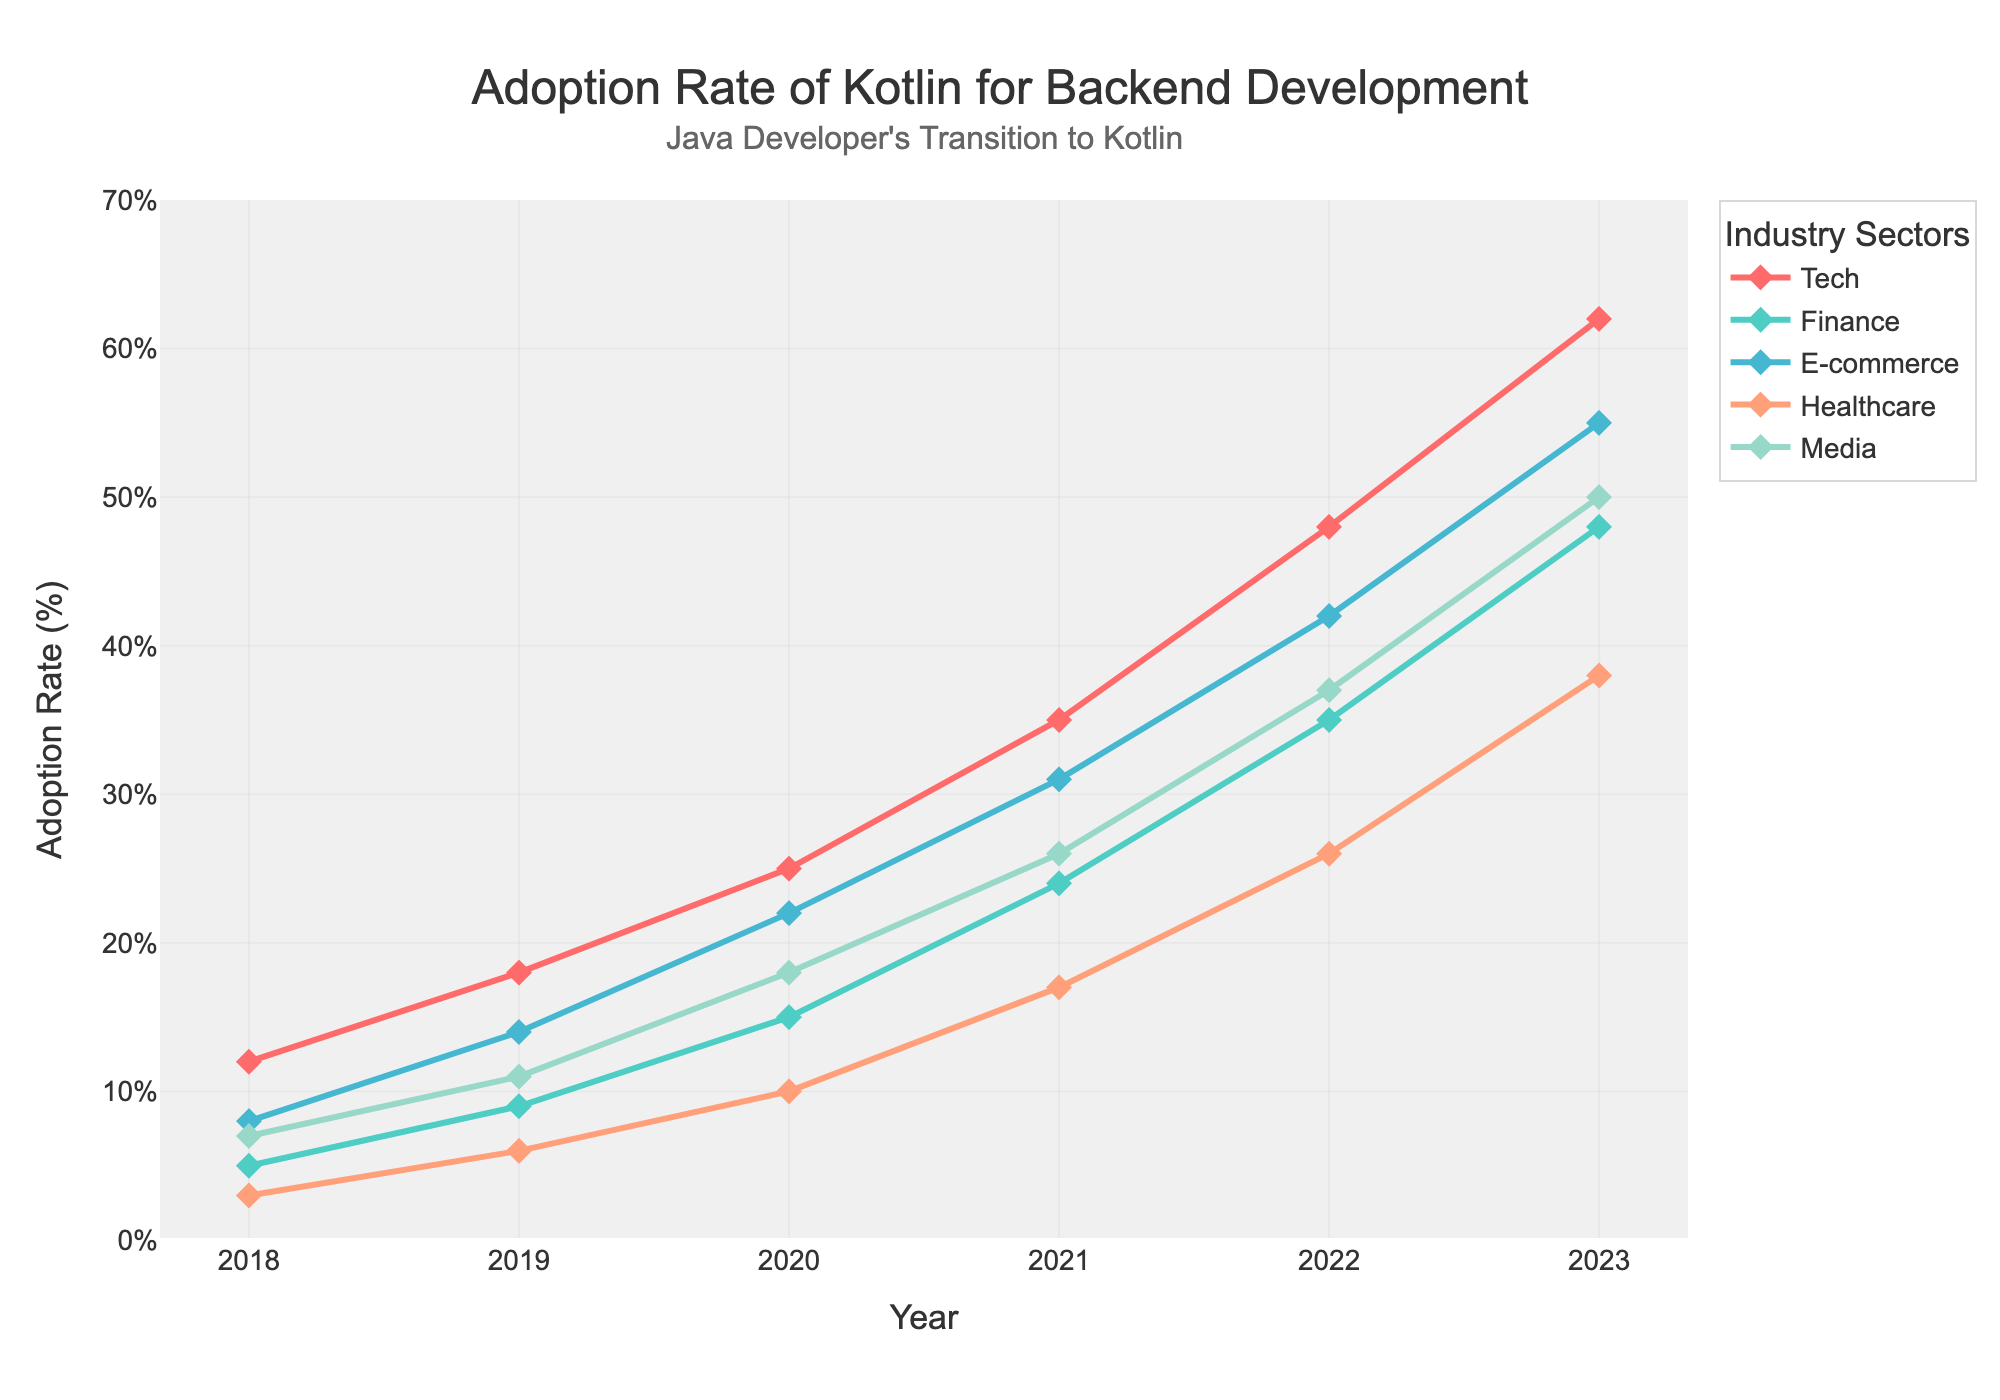What is the adoption rate of Kotlin in the Tech sector in 2020? Look at the line corresponding to the "Tech" sector and find the value for the year 2020.
Answer: 25% Between which years did the Finance sector see the highest increase in Kotlin adoption? Calculate the year-over-year differences in adoption rates for the Finance sector and compare them. The largest increase is between 2022 and 2023 (48 - 35 = 13).
Answer: 2022-2023 Which industry had the highest adoption rate of Kotlin in 2019? Look at the values for 2019 and compare the adoption rates across all industries. Identify the highest value.
Answer: E-commerce By how much did the Healthcare sector's Kotlin adoption increase from 2018 to 2023? Find the values for Healthcare in 2018 and 2023, then calculate the difference (38 - 3 = 35).
Answer: 35 What is the difference in Kotlin adoption rates for Media and Tech in 2021? Compare the adoption rates for Media and Tech in 2021 by subtracting the Media value from the Tech value (35 - 26 = 9).
Answer: 9 Across the years, which sector shows the most consistent increase in Kotlin adoption? Assess the trend lines of each sector visually, noting the consistency of the slope. The Tech sector shows a consistent, steady increase.
Answer: Tech In which year did the E-commerce sector surpass a 40% adoption rate? Locate the year on the E-commerce line that first exceeds 40%.
Answer: 2022 What was the total adoption rate of Kotlin in 2023 across all sectors? Sum the values for all sectors for the year 2023 (62 + 48 + 55 + 38 + 50 = 253).
Answer: 253 Which sector has the steepest slope in their adoption rate from 2021 to 2022? Compare the slopes of each sector between 2021 and 2022 visually, noting the steepest rise. The Tech sector shows the steepest slope.
Answer: Tech How does the adoption rate of Kotlin in the Media sector compare to the Finance sector in 2023? Check the adoption rates for Media and Finance in 2023 and compare them. Media: 50, Finance: 48. Media is slightly higher.
Answer: Media is higher 